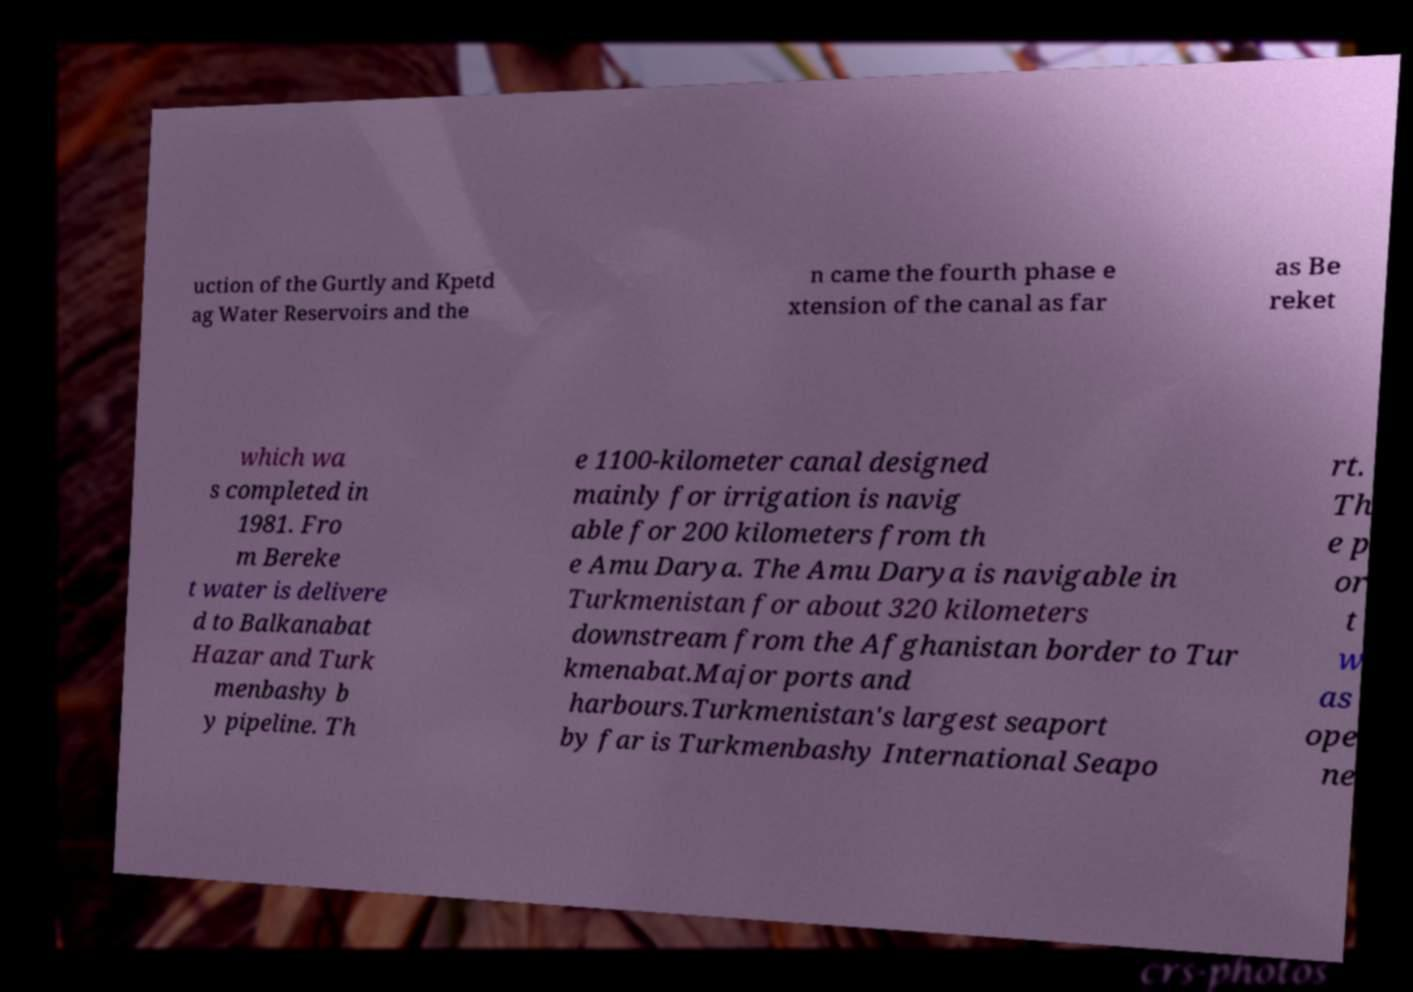There's text embedded in this image that I need extracted. Can you transcribe it verbatim? uction of the Gurtly and Kpetd ag Water Reservoirs and the n came the fourth phase e xtension of the canal as far as Be reket which wa s completed in 1981. Fro m Bereke t water is delivere d to Balkanabat Hazar and Turk menbashy b y pipeline. Th e 1100-kilometer canal designed mainly for irrigation is navig able for 200 kilometers from th e Amu Darya. The Amu Darya is navigable in Turkmenistan for about 320 kilometers downstream from the Afghanistan border to Tur kmenabat.Major ports and harbours.Turkmenistan's largest seaport by far is Turkmenbashy International Seapo rt. Th e p or t w as ope ne 